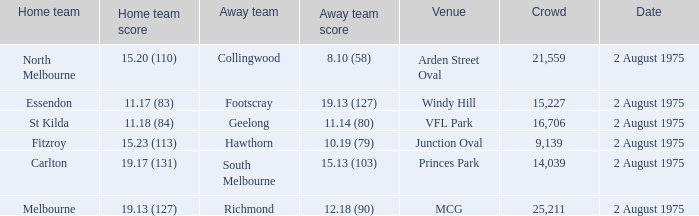Can you parse all the data within this table? {'header': ['Home team', 'Home team score', 'Away team', 'Away team score', 'Venue', 'Crowd', 'Date'], 'rows': [['North Melbourne', '15.20 (110)', 'Collingwood', '8.10 (58)', 'Arden Street Oval', '21,559', '2 August 1975'], ['Essendon', '11.17 (83)', 'Footscray', '19.13 (127)', 'Windy Hill', '15,227', '2 August 1975'], ['St Kilda', '11.18 (84)', 'Geelong', '11.14 (80)', 'VFL Park', '16,706', '2 August 1975'], ['Fitzroy', '15.23 (113)', 'Hawthorn', '10.19 (79)', 'Junction Oval', '9,139', '2 August 1975'], ['Carlton', '19.17 (131)', 'South Melbourne', '15.13 (103)', 'Princes Park', '14,039', '2 August 1975'], ['Melbourne', '19.13 (127)', 'Richmond', '12.18 (90)', 'MCG', '25,211', '2 August 1975']]} Where did the home team score 11.18 (84)? VFL Park. 